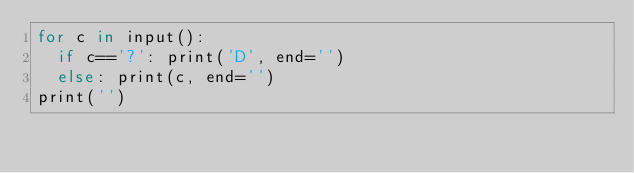Convert code to text. <code><loc_0><loc_0><loc_500><loc_500><_Cython_>for c in input():
  if c=='?': print('D', end='')
  else: print(c, end='')
print('')
</code> 